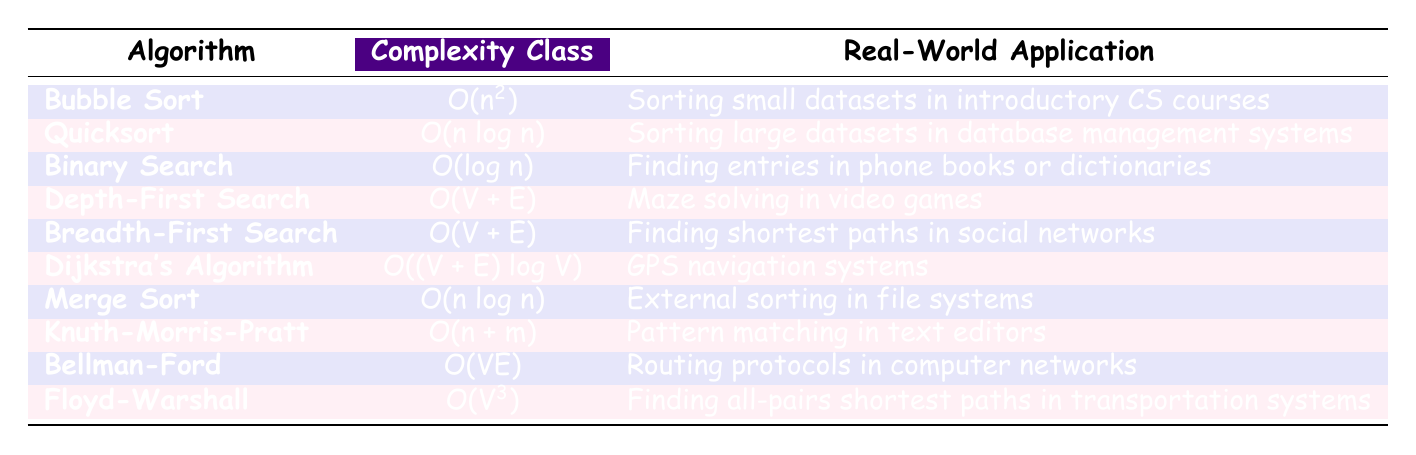What is the complexity class of Quicksort? The table lists Quicksort under the "Complexity Class" column. The corresponding value is "O(n log n)".
Answer: O(n log n) Which algorithm has a complexity class of O(V^3)? By checking the table, we find that the algorithm listed with the complexity class "O(V^3)" is Floyd-Warshall.
Answer: Floyd-Warshall Does Depth-First Search have a higher complexity class than Binary Search? The complexity class of Depth-First Search is "O(V + E)", while Binary Search has "O(log n)". Generally, O(V + E) is considered higher than O(log n), so the answer is yes.
Answer: Yes What is the real-world application of Dijkstra's Algorithm? The table specifies that Dijkstra's Algorithm is used in "GPS navigation systems".
Answer: GPS navigation systems If we consider all algorithms, what is the median of their complexity classes when converted to numeric values? We convert the complexity classes to numeric values for comparison. The values, when sorted, are: n^2, n log n, log n, (V + E), (V + E), (V + E) log V, n log n, (n + m), (V E), V^3. The median is calculated at the center of this ordered list: O(n log n) (for the second instance).
Answer: O(n log n) Which sorting algorithm is listed as applying to external sorting in file systems? Checking the "Real-World Application" column in the table reveals that Merge Sort is used for "External sorting in file systems".
Answer: Merge Sort Is there an algorithm in the table that applies directly to social networks? Browsing through the applications, we find that Breadth-First Search is specifically stated to be for "Finding shortest paths in social networks", confirming that there is indeed an algorithm related to this.
Answer: Yes What is the complexity class of the Knuth-Morris-Pratt algorithm and its real-world application? The complexity class for Knuth-Morris-Pratt is "O(n + m)", and its application is for "Pattern matching in text editors".
Answer: O(n + m), Pattern matching in text editors Which algorithm is typically used for sorting in introductory CS courses? The table shows Bubble Sort listed with the application "Sorting small datasets in introductory CS courses".
Answer: Bubble Sort 